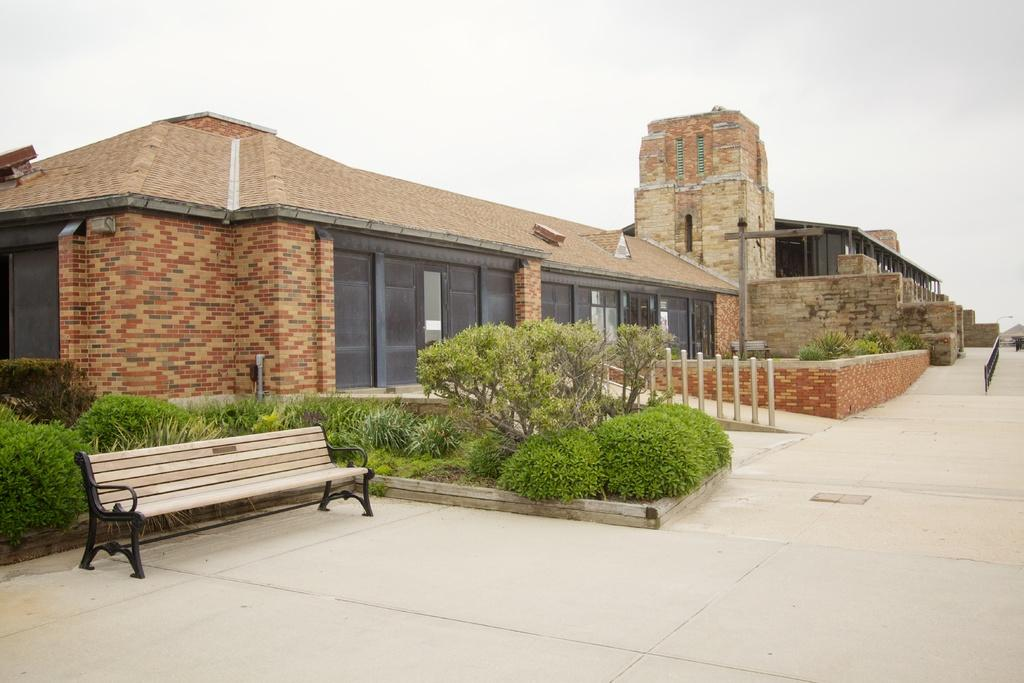What type of structure is in the image? There is a house in the image. What is located in front of the house? There are poles and a bench in front of the house. What type of vegetation is visible in the image? Bushes and plants are visible in the image. What can be seen in the background of the image? A road is visible in the image. What is visible at the top of the image? The sky is visible at the top of the image. How many beasts can be seen running along the road in the image? There are no beasts visible in the image, and therefore no such activity can be observed. What type of train is passing by the house in the image? There is no train present in the image; it only features a house, poles, a bench, bushes, plants, a road, and the sky. 